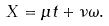Convert formula to latex. <formula><loc_0><loc_0><loc_500><loc_500>X = \mu t + \nu \omega .</formula> 